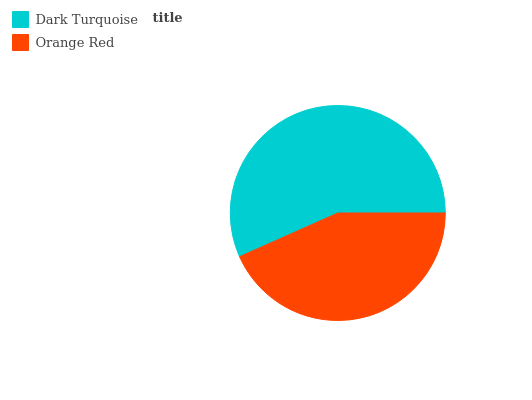Is Orange Red the minimum?
Answer yes or no. Yes. Is Dark Turquoise the maximum?
Answer yes or no. Yes. Is Orange Red the maximum?
Answer yes or no. No. Is Dark Turquoise greater than Orange Red?
Answer yes or no. Yes. Is Orange Red less than Dark Turquoise?
Answer yes or no. Yes. Is Orange Red greater than Dark Turquoise?
Answer yes or no. No. Is Dark Turquoise less than Orange Red?
Answer yes or no. No. Is Dark Turquoise the high median?
Answer yes or no. Yes. Is Orange Red the low median?
Answer yes or no. Yes. Is Orange Red the high median?
Answer yes or no. No. Is Dark Turquoise the low median?
Answer yes or no. No. 